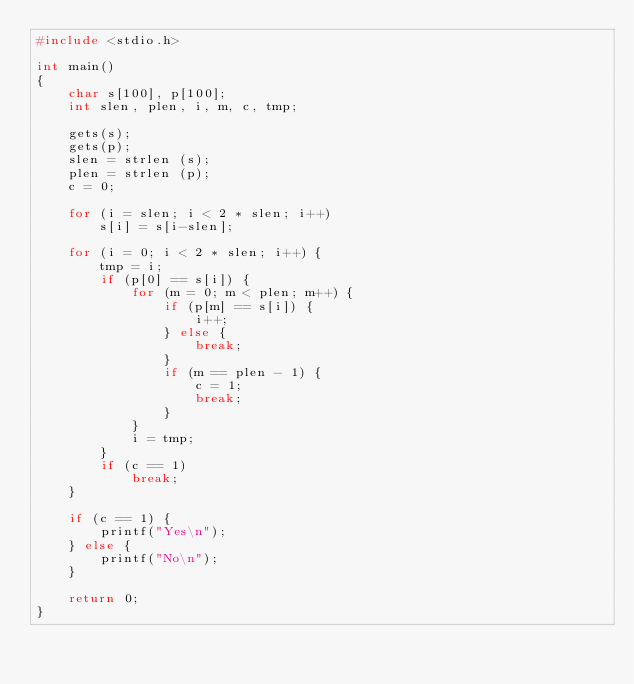<code> <loc_0><loc_0><loc_500><loc_500><_C_>#include <stdio.h>
 
int main()
{
    char s[100], p[100];
    int slen, plen, i, m, c, tmp;

    gets(s);
    gets(p);
    slen = strlen (s);
    plen = strlen (p);
    c = 0;

    for (i = slen; i < 2 * slen; i++)
        s[i] = s[i-slen];

    for (i = 0; i < 2 * slen; i++) {
        tmp = i;
        if (p[0] == s[i]) {
            for (m = 0; m < plen; m++) {
                if (p[m] == s[i]) {
                    i++;
                } else {
                    break;
                }
                if (m == plen - 1) {
                    c = 1;
                    break;
                }
            }
            i = tmp;
        }
        if (c == 1)
            break;
    }

    if (c == 1) {
        printf("Yes\n");
    } else {
        printf("No\n");
    }
    
    return 0;
}</code> 